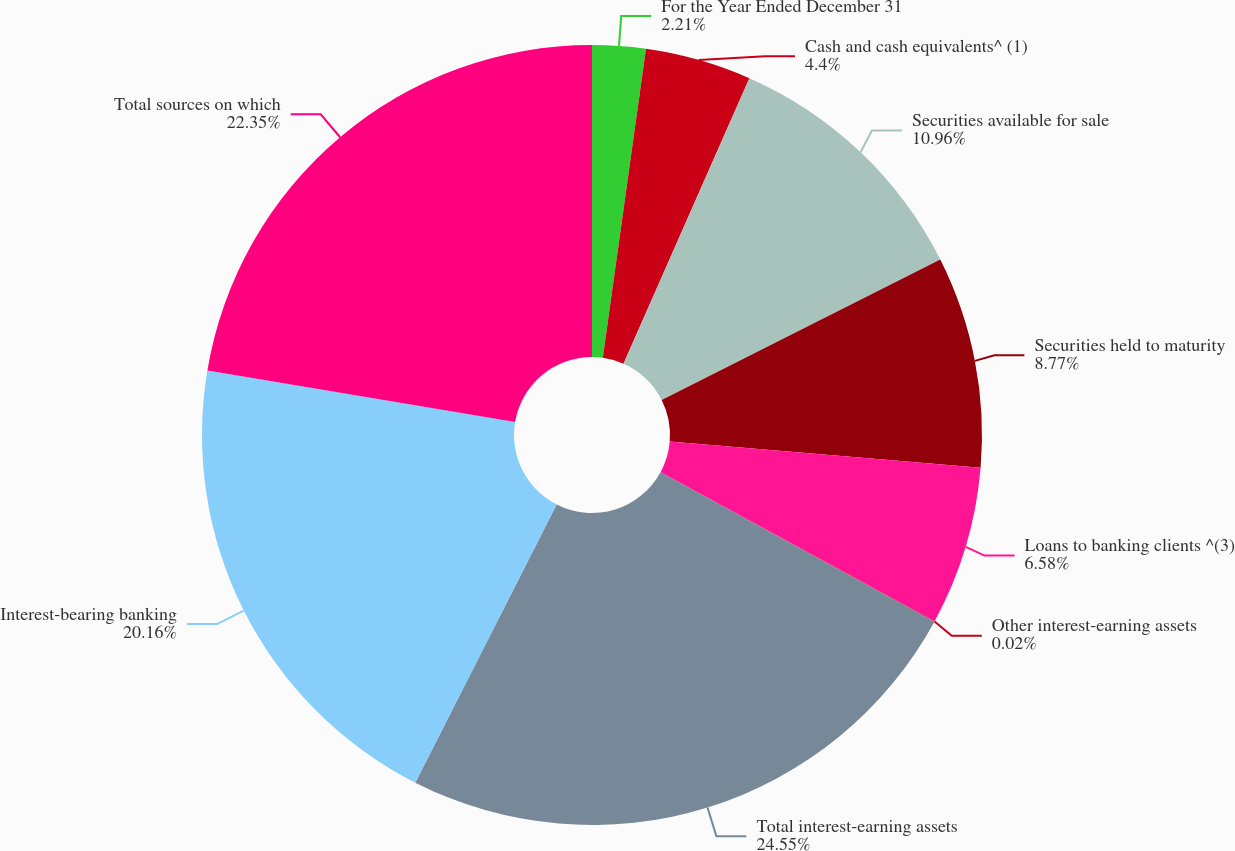Convert chart. <chart><loc_0><loc_0><loc_500><loc_500><pie_chart><fcel>For the Year Ended December 31<fcel>Cash and cash equivalents^ (1)<fcel>Securities available for sale<fcel>Securities held to maturity<fcel>Loans to banking clients ^(3)<fcel>Other interest-earning assets<fcel>Total interest-earning assets<fcel>Interest-bearing banking<fcel>Total sources on which<nl><fcel>2.21%<fcel>4.4%<fcel>10.96%<fcel>8.77%<fcel>6.58%<fcel>0.02%<fcel>24.54%<fcel>20.16%<fcel>22.35%<nl></chart> 